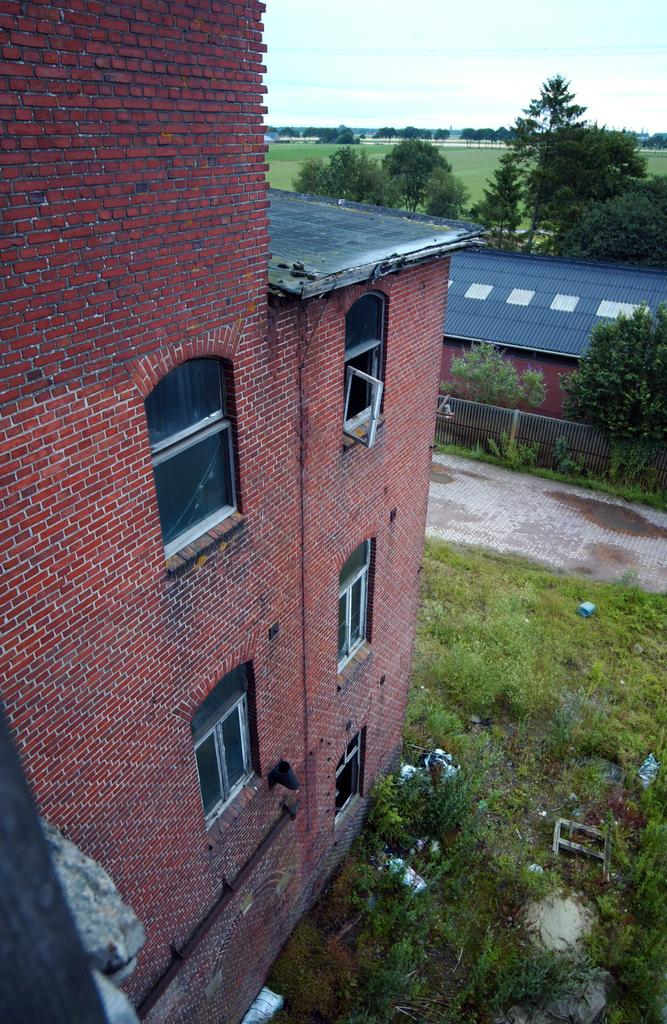What type of structures can be seen in the image? There are buildings in the image. What feature is visible on the buildings? There are windows visible in the image. What type of vegetation is present in the image? There are trees and grass visible in the image. What part of the natural environment is visible in the image? The sky is visible in the image. How many tomatoes are growing on the buildings in the image? There are no tomatoes visible in the image; the focus is on the buildings, windows, trees, grass, and sky. 